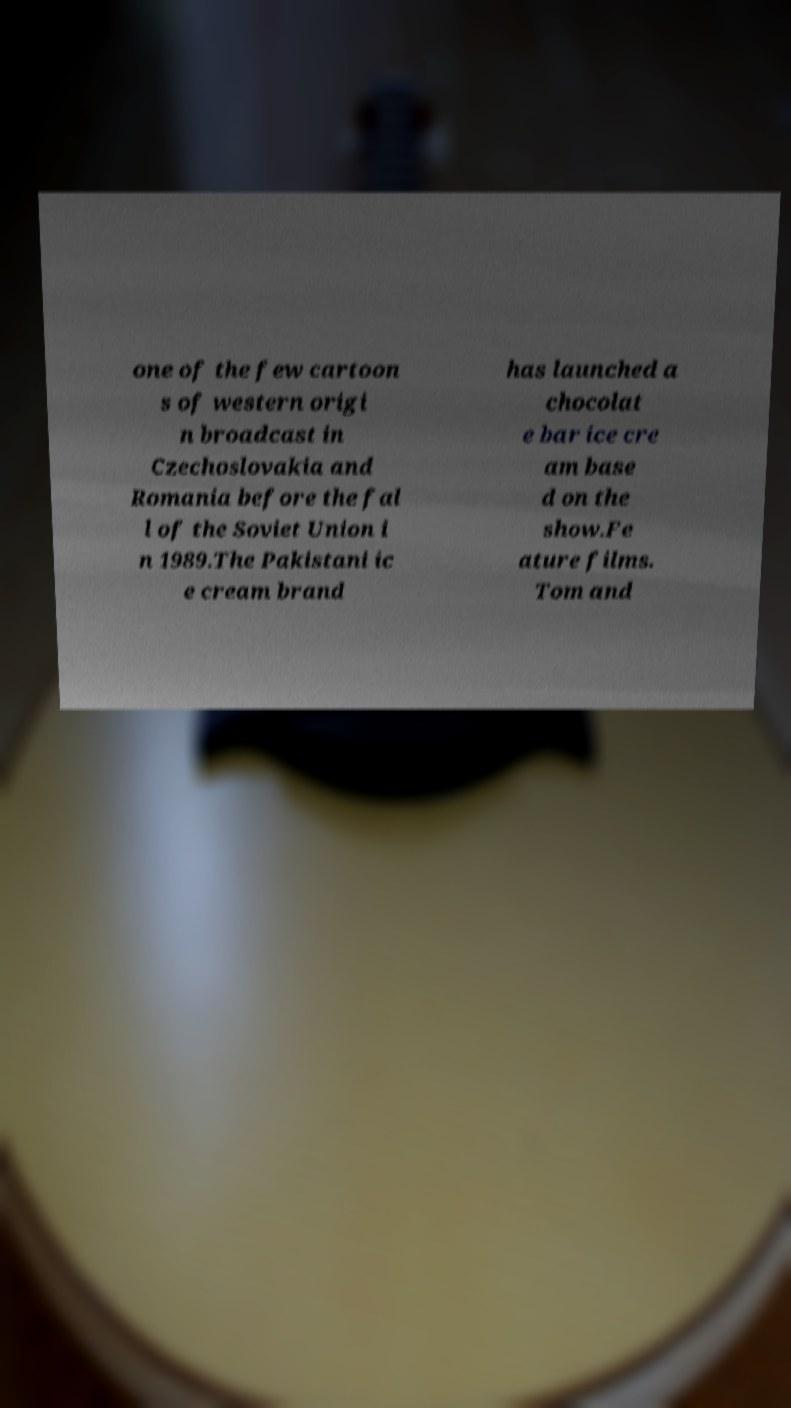Please read and relay the text visible in this image. What does it say? one of the few cartoon s of western origi n broadcast in Czechoslovakia and Romania before the fal l of the Soviet Union i n 1989.The Pakistani ic e cream brand has launched a chocolat e bar ice cre am base d on the show.Fe ature films. Tom and 